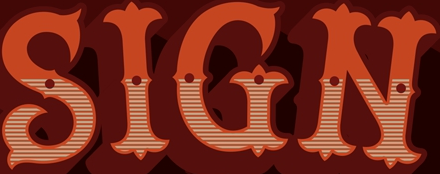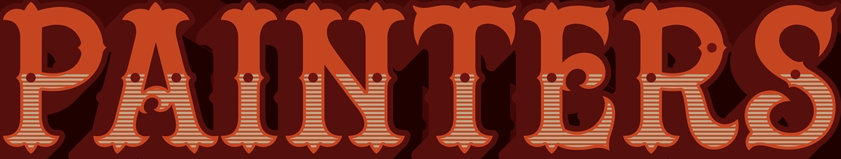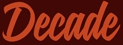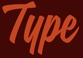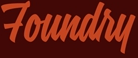What words are shown in these images in order, separated by a semicolon? SIGN; PAINTERS; Decade; Type; Foundry 